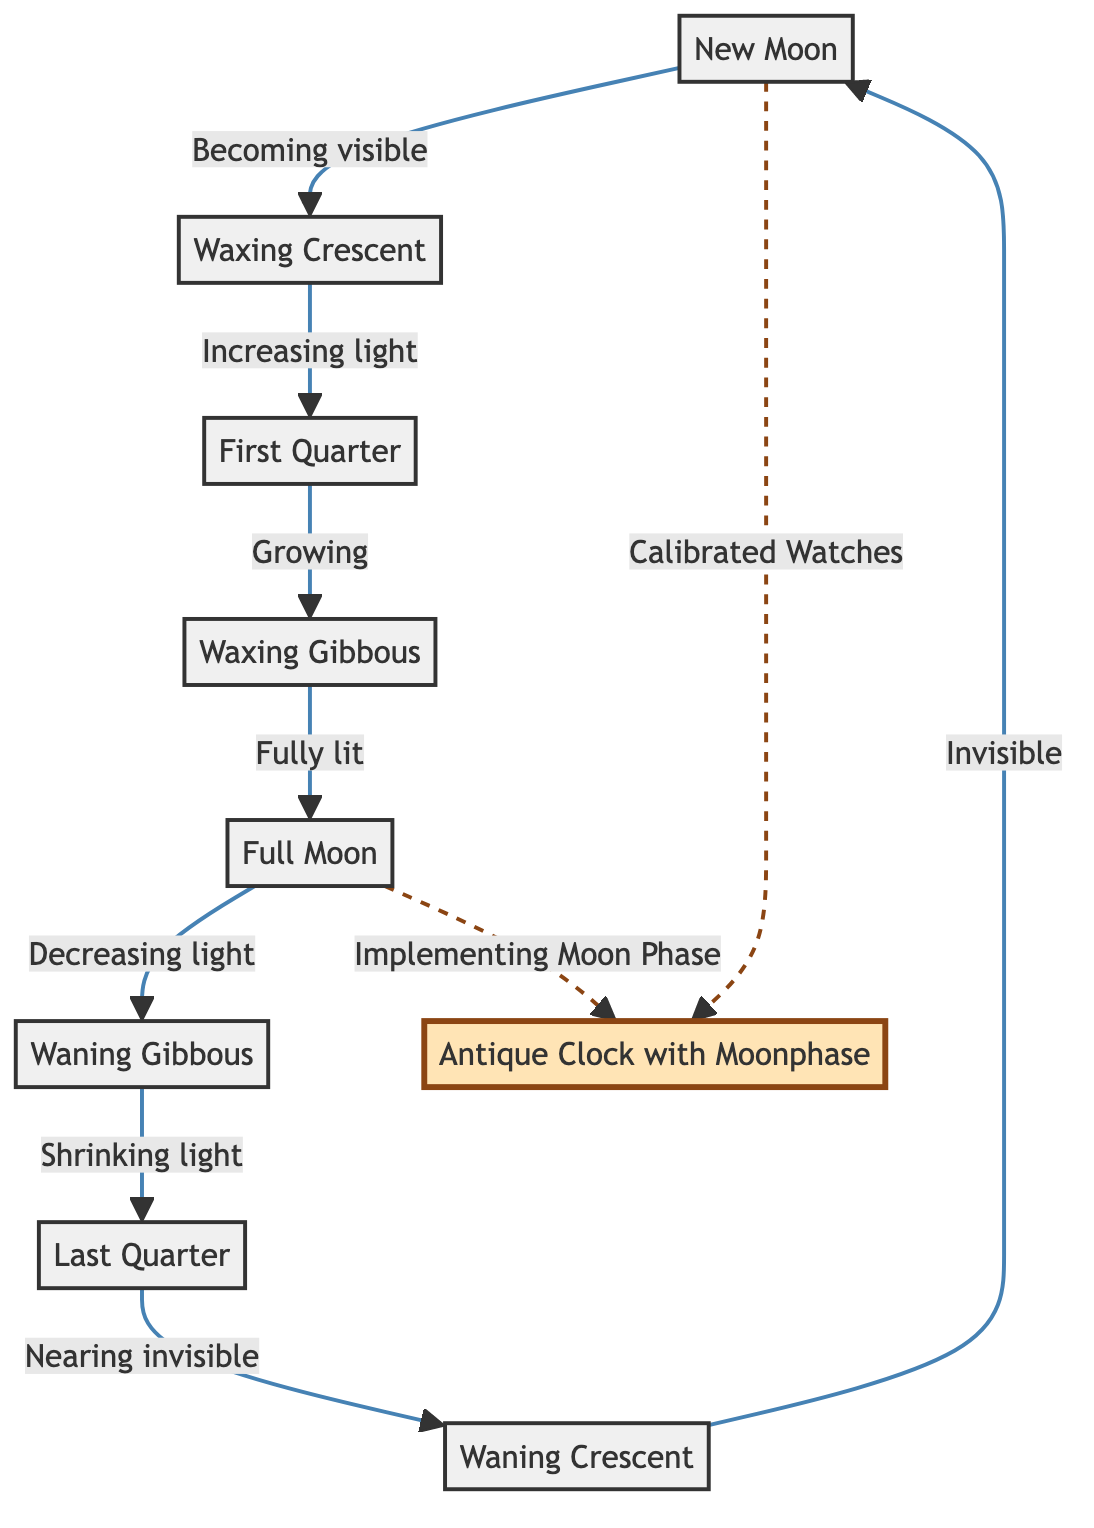What are the phases of the Moon shown in the diagram? The diagram lists the phases of the Moon as follows: New Moon, Waxing Crescent, First Quarter, Waxing Gibbous, Full Moon, Waning Gibbous, Last Quarter, and Waning Crescent.
Answer: Eight phases What phase comes after the First Quarter? By following the flow of the diagram from the First Quarter, the next phase is Waxing Gibbous.
Answer: Waxing Gibbous Which phase is represented as "Fully lit"? The diagram identifies the phase that is "Fully lit" as the Full Moon.
Answer: Full Moon How many connections are there from New Moon to other phases? From the New Moon phase, there are two direct connections (to Waxing Crescent and an indirect one to Antique Clock).
Answer: Two connections What is indicated by the dashed line to the Antique Clock from both New Moon and Full Moon? The dashed line signifies that both the New Moon and the Full Moon phases are related to the mechanisms of calibrating watches and implementing moon phases in antique clocks.
Answer: Calibrated Watches, Implementing Moon Phase Which phase precedes the Waning Gibbous phase? Tracing the diagram back from Waning Gibbous shows that the phase preceding it is Full Moon.
Answer: Full Moon What is the relationship between New Moon and antique clocks? The New Moon phase is linked to calibrated watches, indicating its influence on antique clocks in terms of moonphase tracking.
Answer: Calibrated Watches Name the final phase before returning to the New Moon. The diagram indicates that the last phase before cycling back to the New Moon is Waning Crescent.
Answer: Waning Crescent 